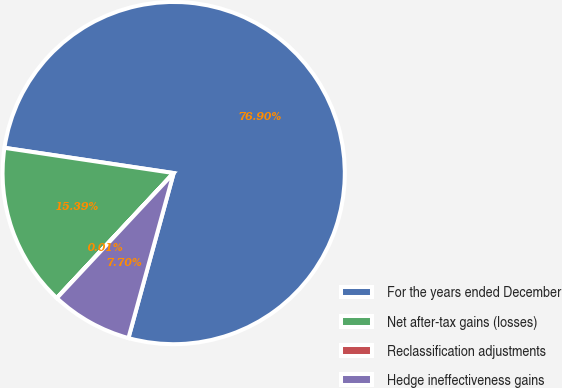Convert chart to OTSL. <chart><loc_0><loc_0><loc_500><loc_500><pie_chart><fcel>For the years ended December<fcel>Net after-tax gains (losses)<fcel>Reclassification adjustments<fcel>Hedge ineffectiveness gains<nl><fcel>76.91%<fcel>15.39%<fcel>0.01%<fcel>7.7%<nl></chart> 